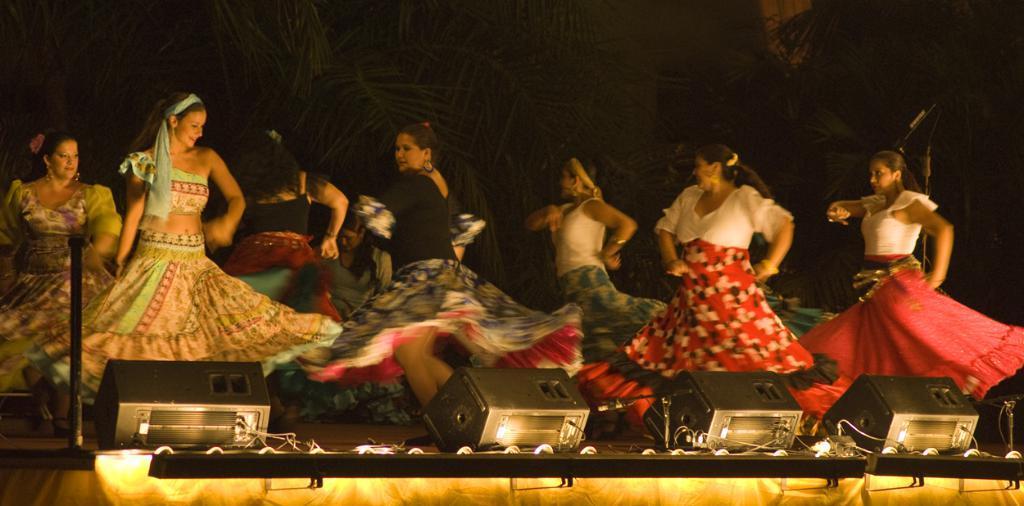In one or two sentences, can you explain what this image depicts? In the center of the image we can see ladies dancing. At the bottom there are speakers and lights. In the background there are trees. 